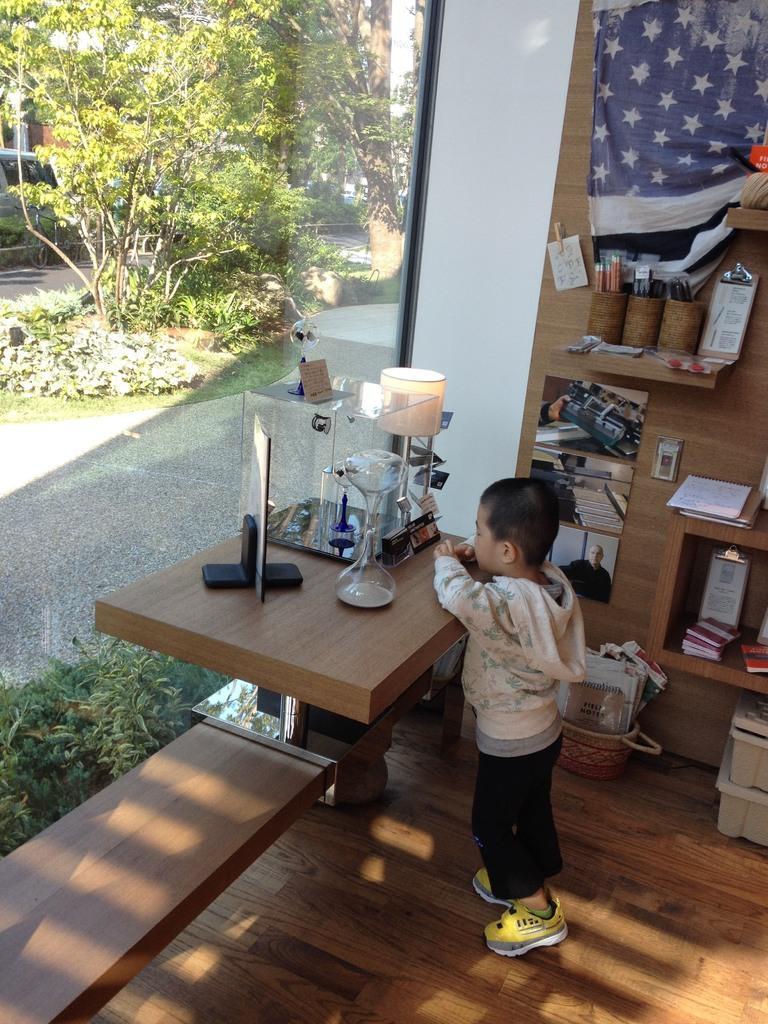Can you describe this image briefly? As we can see in the image, there are trees, plants and a boy standing on floor. 